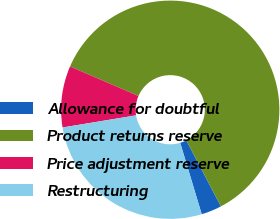Convert chart to OTSL. <chart><loc_0><loc_0><loc_500><loc_500><pie_chart><fcel>Allowance for doubtful<fcel>Product returns reserve<fcel>Price adjustment reserve<fcel>Restructuring<nl><fcel>3.03%<fcel>60.82%<fcel>9.09%<fcel>27.05%<nl></chart> 